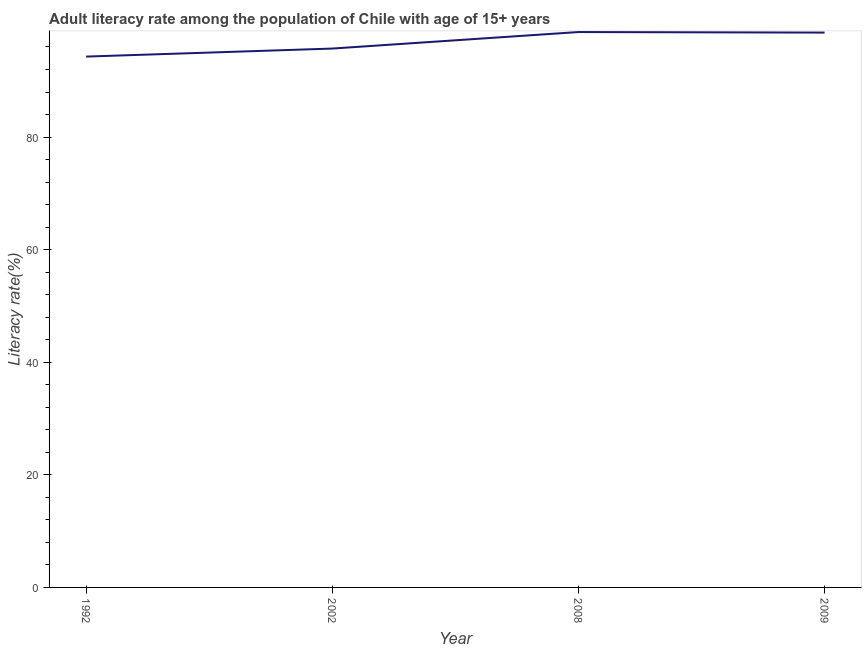What is the adult literacy rate in 2002?
Your response must be concise. 95.72. Across all years, what is the maximum adult literacy rate?
Ensure brevity in your answer.  98.65. Across all years, what is the minimum adult literacy rate?
Give a very brief answer. 94.29. In which year was the adult literacy rate minimum?
Give a very brief answer. 1992. What is the sum of the adult literacy rate?
Keep it short and to the point. 387.21. What is the difference between the adult literacy rate in 2002 and 2009?
Make the answer very short. -2.84. What is the average adult literacy rate per year?
Give a very brief answer. 96.8. What is the median adult literacy rate?
Your response must be concise. 97.14. What is the ratio of the adult literacy rate in 1992 to that in 2002?
Give a very brief answer. 0.99. Is the adult literacy rate in 2002 less than that in 2009?
Offer a terse response. Yes. What is the difference between the highest and the second highest adult literacy rate?
Keep it short and to the point. 0.1. Is the sum of the adult literacy rate in 2008 and 2009 greater than the maximum adult literacy rate across all years?
Your answer should be very brief. Yes. What is the difference between the highest and the lowest adult literacy rate?
Your answer should be very brief. 4.36. Does the adult literacy rate monotonically increase over the years?
Your response must be concise. No. How many lines are there?
Offer a terse response. 1. How many years are there in the graph?
Provide a short and direct response. 4. What is the difference between two consecutive major ticks on the Y-axis?
Ensure brevity in your answer.  20. Are the values on the major ticks of Y-axis written in scientific E-notation?
Keep it short and to the point. No. Does the graph contain any zero values?
Offer a very short reply. No. Does the graph contain grids?
Your answer should be very brief. No. What is the title of the graph?
Your answer should be compact. Adult literacy rate among the population of Chile with age of 15+ years. What is the label or title of the Y-axis?
Your answer should be very brief. Literacy rate(%). What is the Literacy rate(%) in 1992?
Offer a terse response. 94.29. What is the Literacy rate(%) of 2002?
Your answer should be compact. 95.72. What is the Literacy rate(%) of 2008?
Provide a short and direct response. 98.65. What is the Literacy rate(%) in 2009?
Your response must be concise. 98.55. What is the difference between the Literacy rate(%) in 1992 and 2002?
Keep it short and to the point. -1.43. What is the difference between the Literacy rate(%) in 1992 and 2008?
Ensure brevity in your answer.  -4.36. What is the difference between the Literacy rate(%) in 1992 and 2009?
Provide a short and direct response. -4.26. What is the difference between the Literacy rate(%) in 2002 and 2008?
Provide a short and direct response. -2.93. What is the difference between the Literacy rate(%) in 2002 and 2009?
Keep it short and to the point. -2.84. What is the difference between the Literacy rate(%) in 2008 and 2009?
Provide a succinct answer. 0.1. What is the ratio of the Literacy rate(%) in 1992 to that in 2008?
Your answer should be very brief. 0.96. What is the ratio of the Literacy rate(%) in 1992 to that in 2009?
Ensure brevity in your answer.  0.96. 